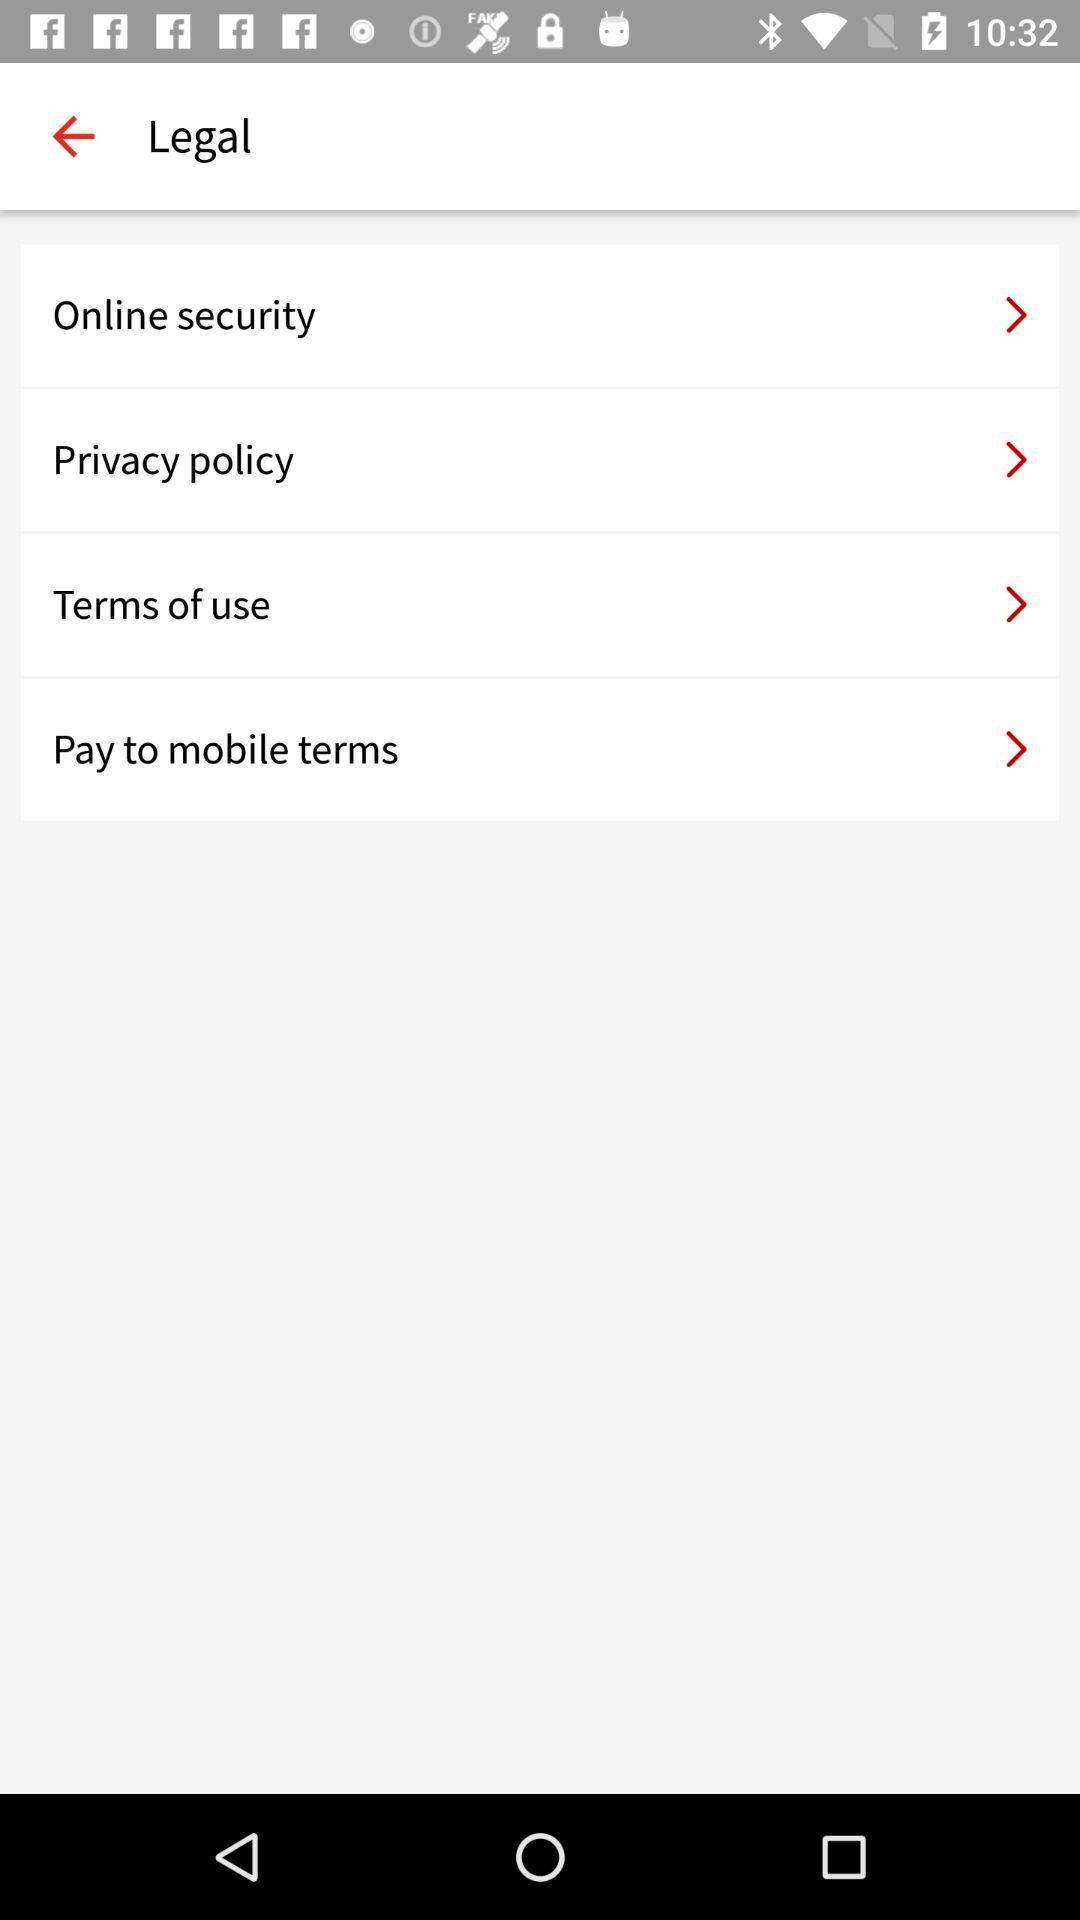How many terms of service do I need to agree to? 4 